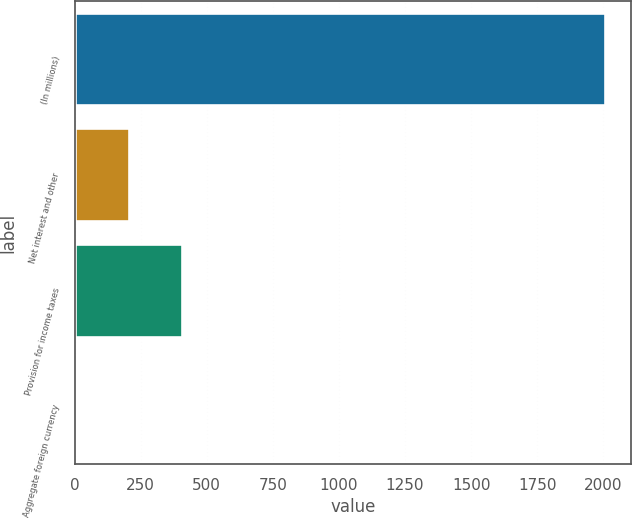Convert chart. <chart><loc_0><loc_0><loc_500><loc_500><bar_chart><fcel>(In millions)<fcel>Net interest and other<fcel>Provision for income taxes<fcel>Aggregate foreign currency<nl><fcel>2006<fcel>206<fcel>406<fcel>6<nl></chart> 